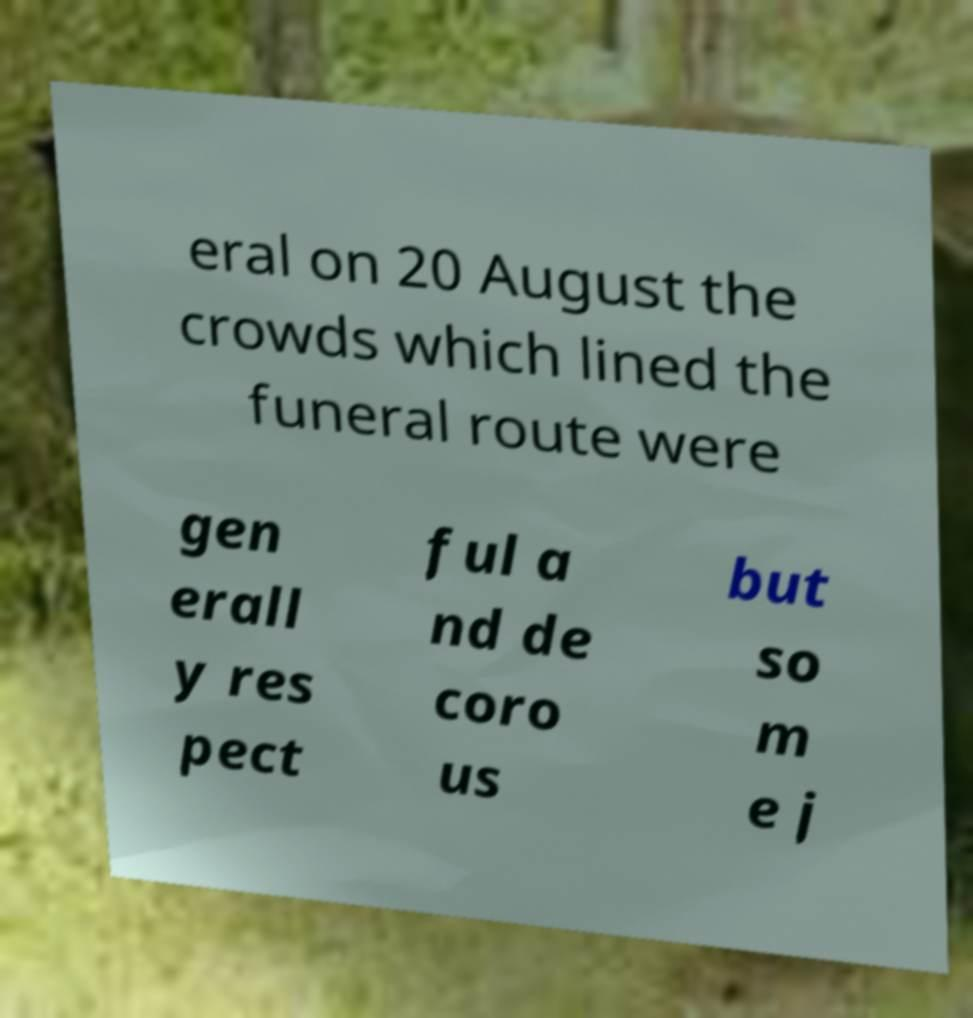For documentation purposes, I need the text within this image transcribed. Could you provide that? eral on 20 August the crowds which lined the funeral route were gen erall y res pect ful a nd de coro us but so m e j 